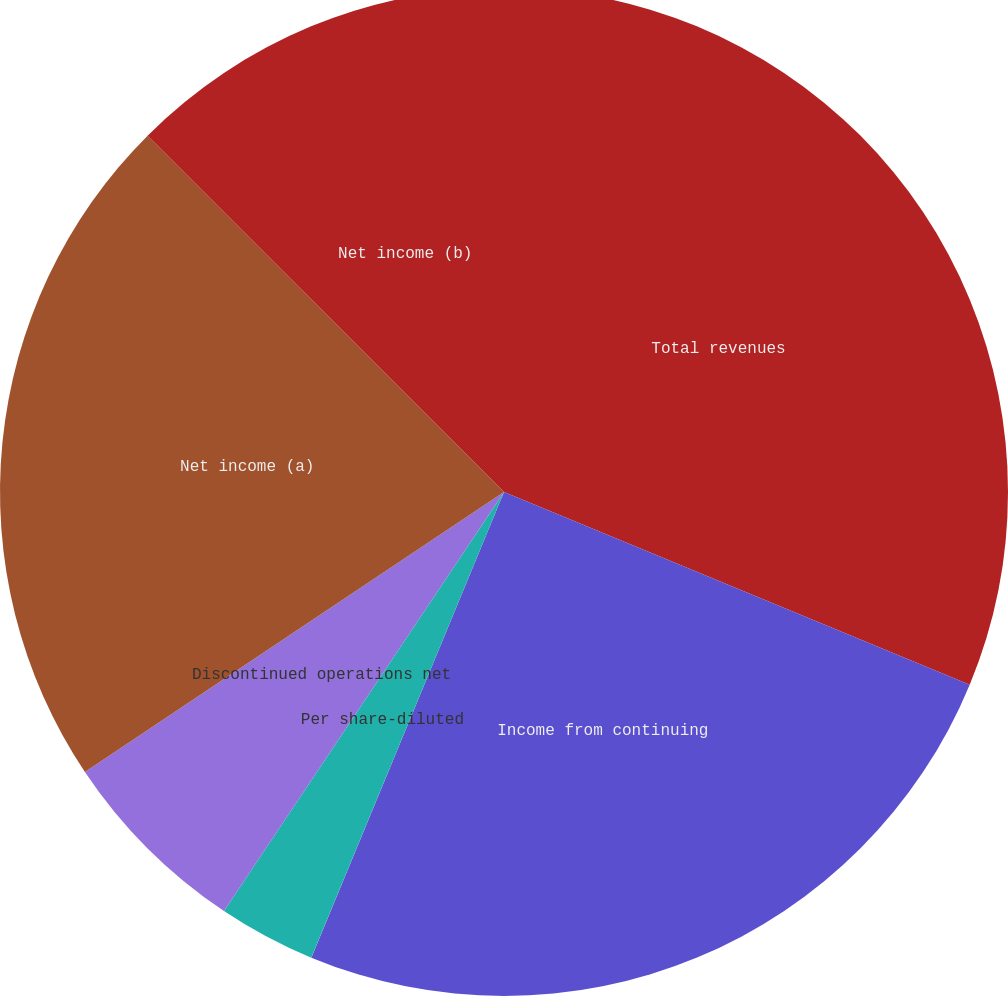Convert chart. <chart><loc_0><loc_0><loc_500><loc_500><pie_chart><fcel>Total revenues<fcel>Income from continuing<fcel>Per share-basic<fcel>Per share-diluted<fcel>Discontinued operations net<fcel>Net income (a)<fcel>Net income (b)<nl><fcel>31.24%<fcel>25.0%<fcel>0.0%<fcel>3.13%<fcel>6.25%<fcel>21.87%<fcel>12.5%<nl></chart> 